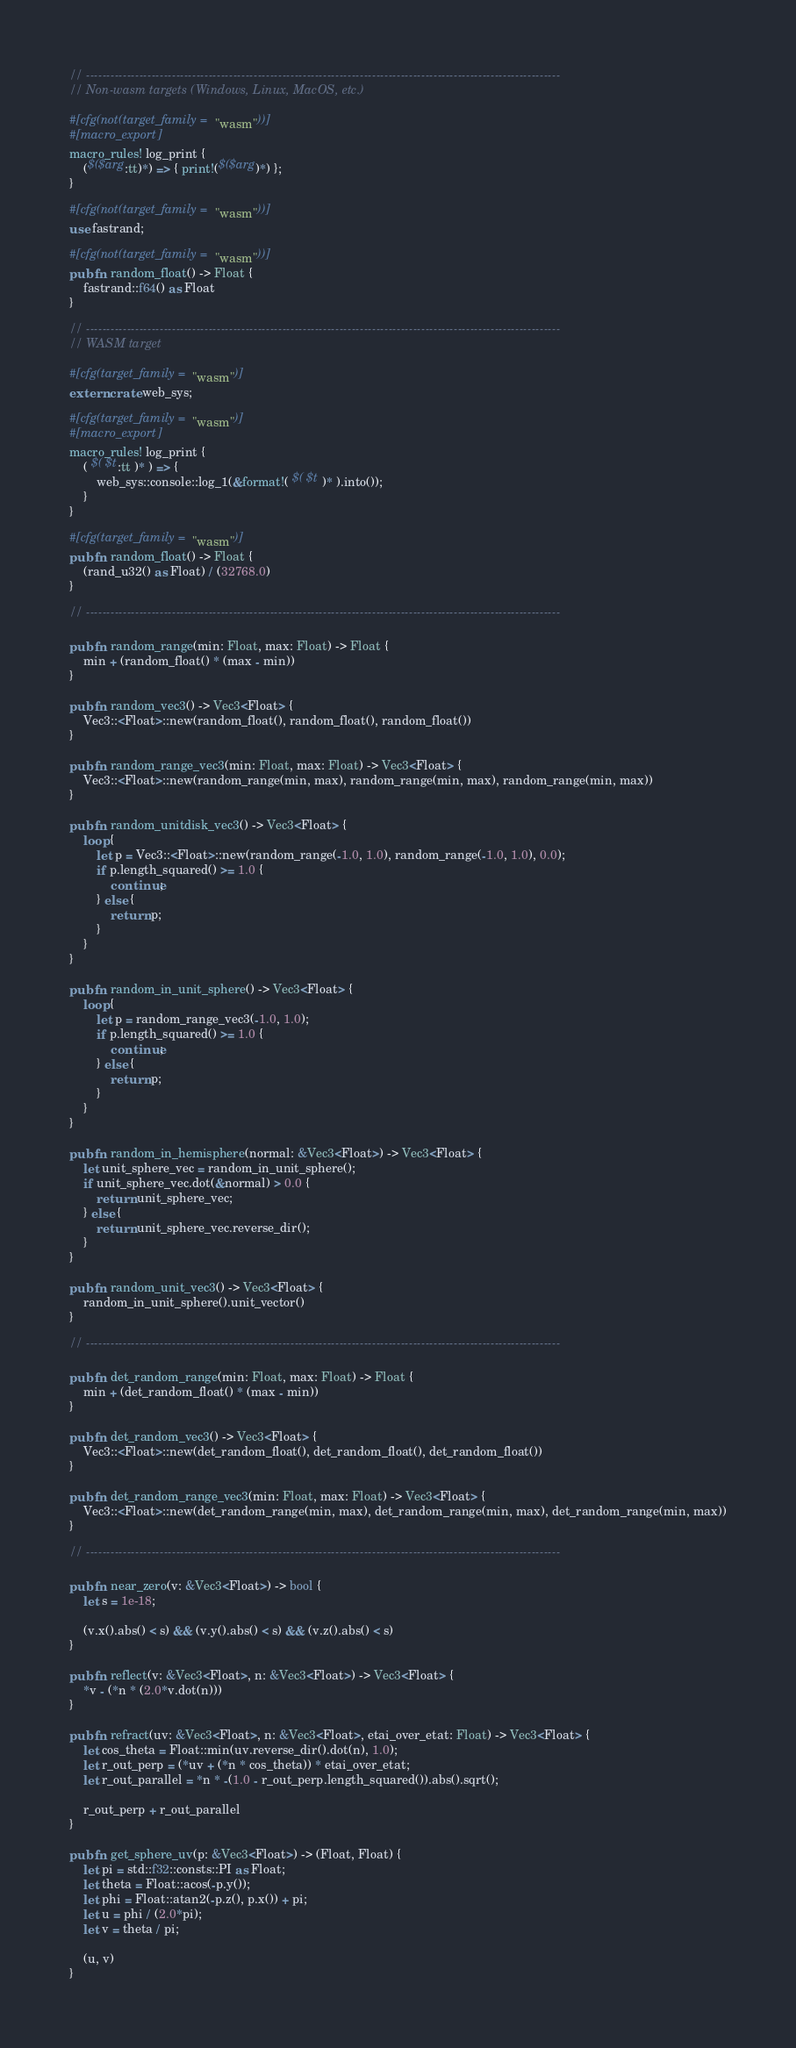Convert code to text. <code><loc_0><loc_0><loc_500><loc_500><_Rust_>// --------------------------------------------------------------------------------------------------------------------
// Non-wasm targets (Windows, Linux, MacOS, etc.)

#[cfg(not(target_family = "wasm"))]
#[macro_export]
macro_rules! log_print {
    ($($arg:tt)*) => { print!($($arg)*) };
}

#[cfg(not(target_family = "wasm"))]
use fastrand;

#[cfg(not(target_family = "wasm"))]
pub fn random_float() -> Float {
    fastrand::f64() as Float
}

// --------------------------------------------------------------------------------------------------------------------
// WASM target

#[cfg(target_family = "wasm")]
extern crate web_sys;

#[cfg(target_family = "wasm")]
#[macro_export]
macro_rules! log_print {
    ( $( $t:tt )* ) => {
        web_sys::console::log_1(&format!( $( $t )* ).into());
    }
}

#[cfg(target_family = "wasm")]
pub fn random_float() -> Float {
    (rand_u32() as Float) / (32768.0)
}

// --------------------------------------------------------------------------------------------------------------------

pub fn random_range(min: Float, max: Float) -> Float {
    min + (random_float() * (max - min))
}

pub fn random_vec3() -> Vec3<Float> {
    Vec3::<Float>::new(random_float(), random_float(), random_float())
}

pub fn random_range_vec3(min: Float, max: Float) -> Vec3<Float> {
    Vec3::<Float>::new(random_range(min, max), random_range(min, max), random_range(min, max))
}

pub fn random_unitdisk_vec3() -> Vec3<Float> {
    loop {
        let p = Vec3::<Float>::new(random_range(-1.0, 1.0), random_range(-1.0, 1.0), 0.0);
        if p.length_squared() >= 1.0 {
            continue;
        } else {
            return p;
        }
    }
}

pub fn random_in_unit_sphere() -> Vec3<Float> {
    loop {
        let p = random_range_vec3(-1.0, 1.0);
        if p.length_squared() >= 1.0 {
            continue;
        } else {
            return p;
        }
    }
}

pub fn random_in_hemisphere(normal: &Vec3<Float>) -> Vec3<Float> {
    let unit_sphere_vec = random_in_unit_sphere();
    if unit_sphere_vec.dot(&normal) > 0.0 {
        return unit_sphere_vec;
    } else {
        return unit_sphere_vec.reverse_dir();
    }
}

pub fn random_unit_vec3() -> Vec3<Float> {
    random_in_unit_sphere().unit_vector()
}

// --------------------------------------------------------------------------------------------------------------------

pub fn det_random_range(min: Float, max: Float) -> Float {
    min + (det_random_float() * (max - min))
}

pub fn det_random_vec3() -> Vec3<Float> {
    Vec3::<Float>::new(det_random_float(), det_random_float(), det_random_float())
}

pub fn det_random_range_vec3(min: Float, max: Float) -> Vec3<Float> {
    Vec3::<Float>::new(det_random_range(min, max), det_random_range(min, max), det_random_range(min, max))
}

// --------------------------------------------------------------------------------------------------------------------

pub fn near_zero(v: &Vec3<Float>) -> bool {
    let s = 1e-18;

    (v.x().abs() < s) && (v.y().abs() < s) && (v.z().abs() < s)
}

pub fn reflect(v: &Vec3<Float>, n: &Vec3<Float>) -> Vec3<Float> {
    *v - (*n * (2.0*v.dot(n)))
}

pub fn refract(uv: &Vec3<Float>, n: &Vec3<Float>, etai_over_etat: Float) -> Vec3<Float> {
    let cos_theta = Float::min(uv.reverse_dir().dot(n), 1.0);
    let r_out_perp = (*uv + (*n * cos_theta)) * etai_over_etat;
    let r_out_parallel = *n * -(1.0 - r_out_perp.length_squared()).abs().sqrt();

    r_out_perp + r_out_parallel
}

pub fn get_sphere_uv(p: &Vec3<Float>) -> (Float, Float) {
    let pi = std::f32::consts::PI as Float;
    let theta = Float::acos(-p.y());
    let phi = Float::atan2(-p.z(), p.x()) + pi;
    let u = phi / (2.0*pi);
    let v = theta / pi;

    (u, v)
}</code> 